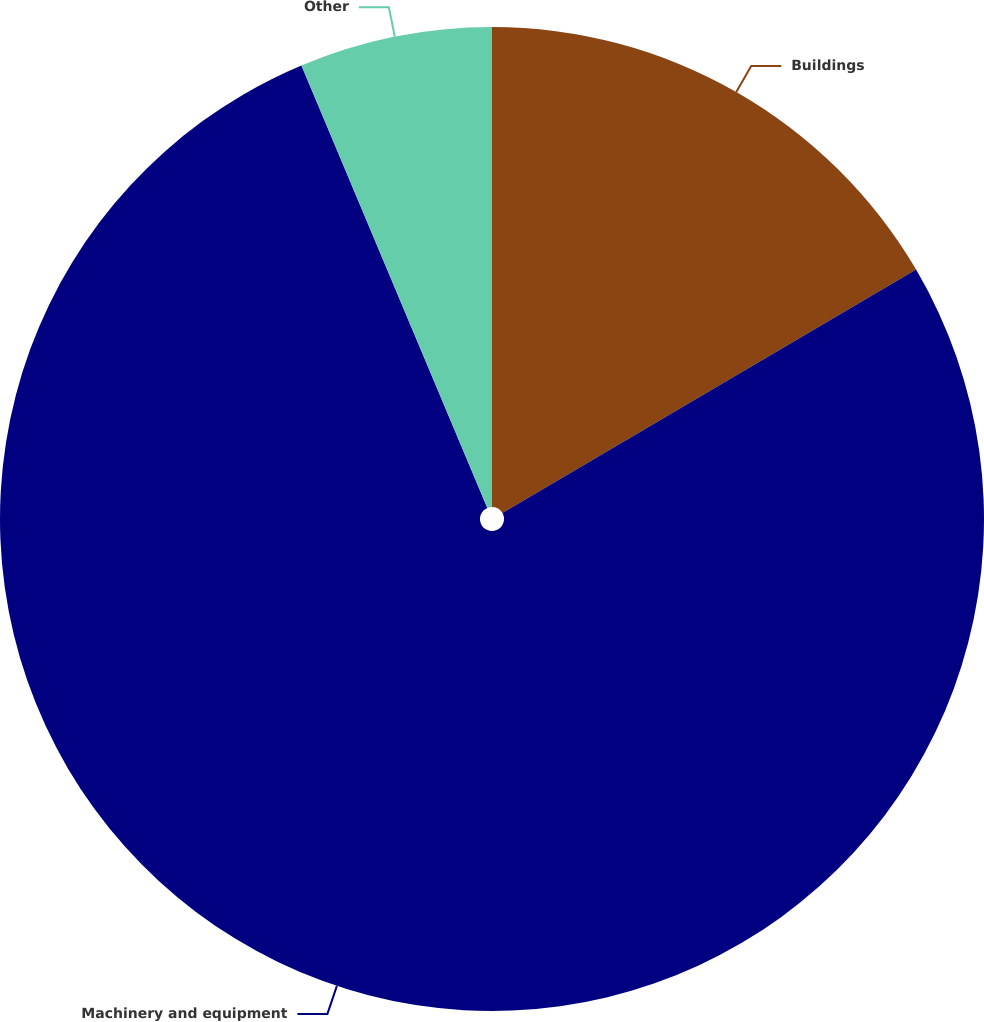Convert chart to OTSL. <chart><loc_0><loc_0><loc_500><loc_500><pie_chart><fcel>Buildings<fcel>Machinery and equipment<fcel>Other<nl><fcel>16.54%<fcel>77.13%<fcel>6.33%<nl></chart> 